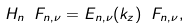Convert formula to latex. <formula><loc_0><loc_0><loc_500><loc_500>H _ { n } \ F _ { n , \nu } = E _ { n , \nu } ( k _ { z } ) \ F _ { n , \nu } ,</formula> 